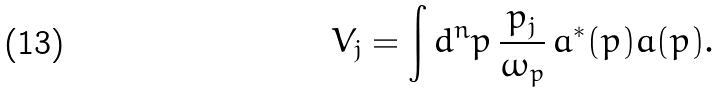Convert formula to latex. <formula><loc_0><loc_0><loc_500><loc_500>V _ { j } & = \int d ^ { n } p \, \frac { p _ { j } } { \omega _ { p } } \, { a } ^ { * } ( p ) { a } ( p ) .</formula> 